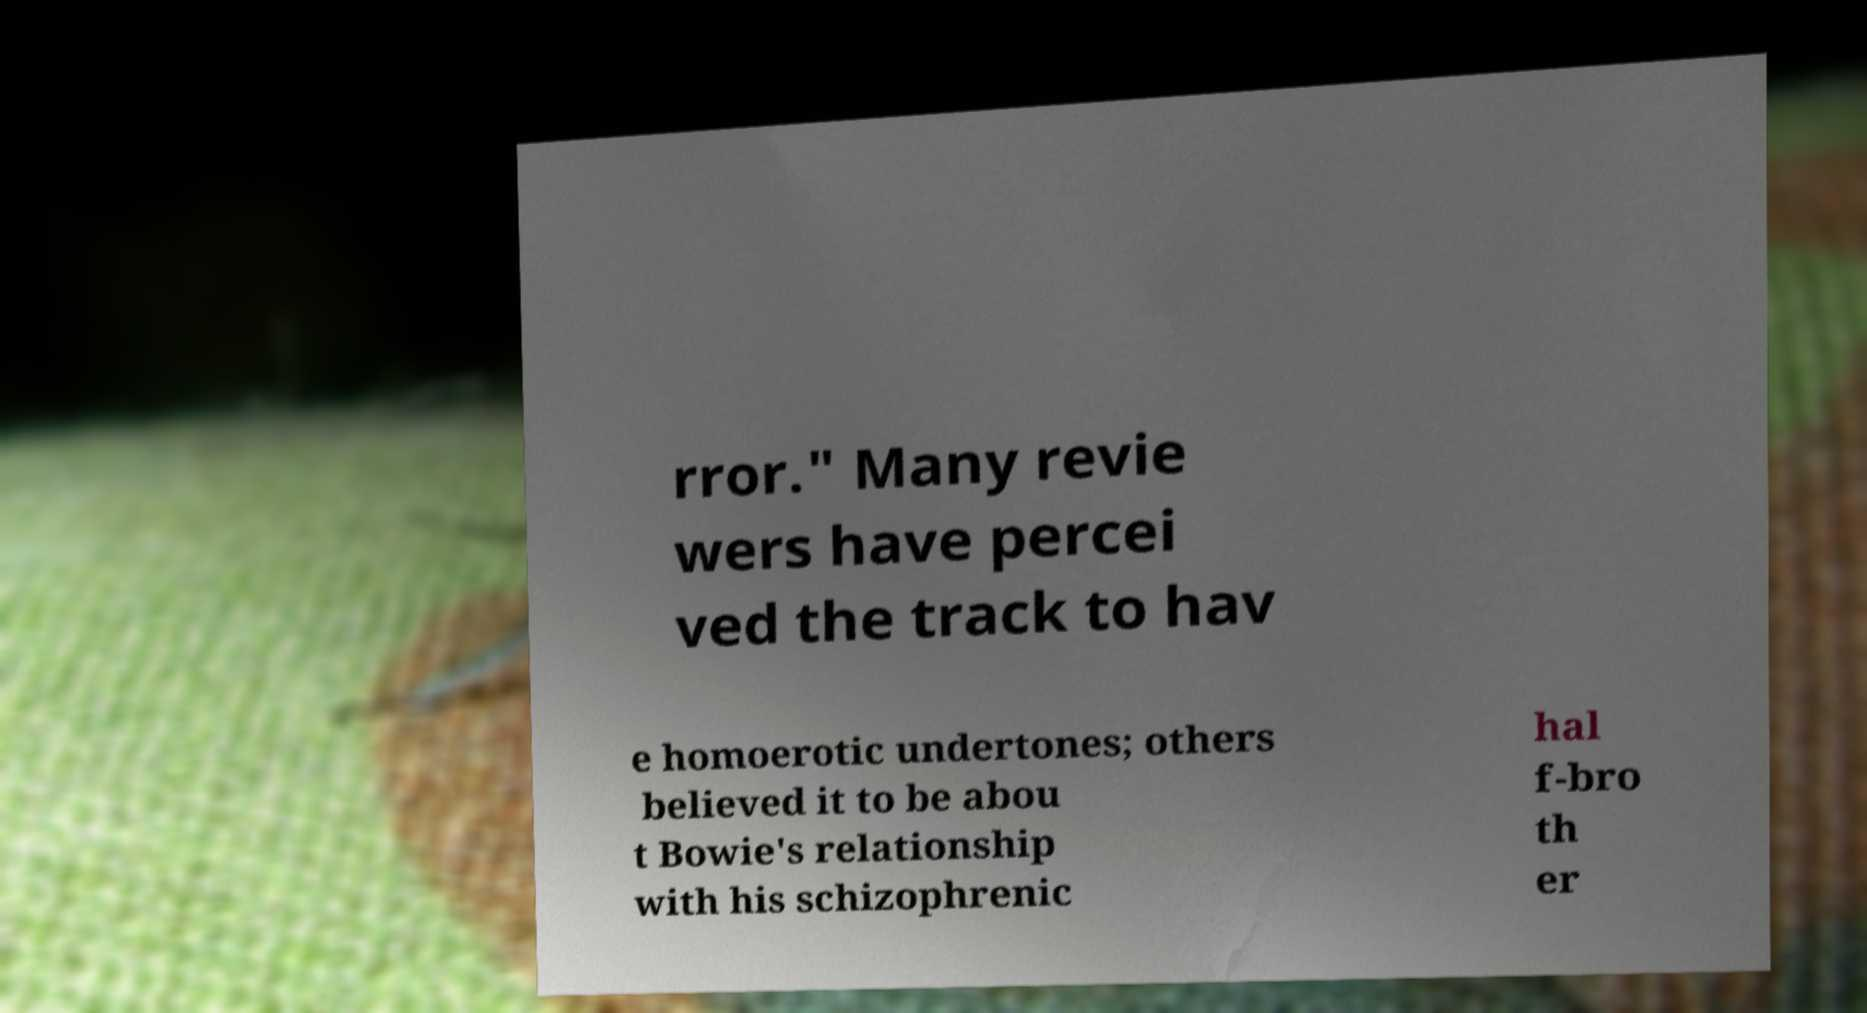Can you read and provide the text displayed in the image?This photo seems to have some interesting text. Can you extract and type it out for me? rror." Many revie wers have percei ved the track to hav e homoerotic undertones; others believed it to be abou t Bowie's relationship with his schizophrenic hal f-bro th er 